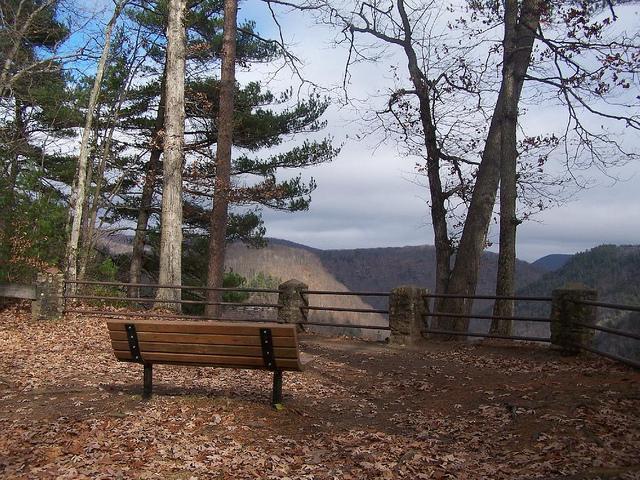How many pink teddy bears are there?
Give a very brief answer. 0. 